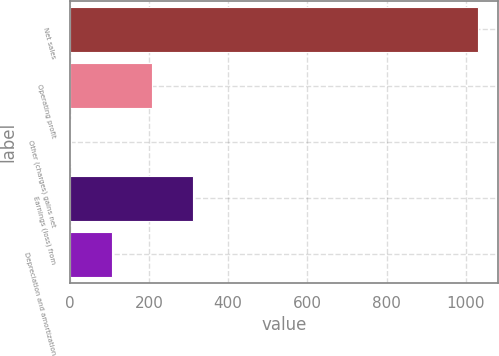Convert chart to OTSL. <chart><loc_0><loc_0><loc_500><loc_500><bar_chart><fcel>Net sales<fcel>Operating profit<fcel>Other (charges) gains net<fcel>Earnings (loss) from<fcel>Depreciation and amortization<nl><fcel>1030<fcel>209.2<fcel>4<fcel>311.8<fcel>106.6<nl></chart> 